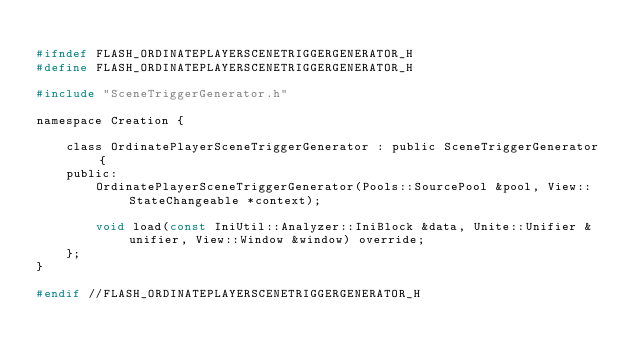Convert code to text. <code><loc_0><loc_0><loc_500><loc_500><_C_>
#ifndef FLASH_ORDINATEPLAYERSCENETRIGGERGENERATOR_H
#define FLASH_ORDINATEPLAYERSCENETRIGGERGENERATOR_H

#include "SceneTriggerGenerator.h"

namespace Creation {

    class OrdinatePlayerSceneTriggerGenerator : public SceneTriggerGenerator {
    public:
        OrdinatePlayerSceneTriggerGenerator(Pools::SourcePool &pool, View::StateChangeable *context);

        void load(const IniUtil::Analyzer::IniBlock &data, Unite::Unifier &unifier, View::Window &window) override;
    };
}

#endif //FLASH_ORDINATEPLAYERSCENETRIGGERGENERATOR_H
</code> 